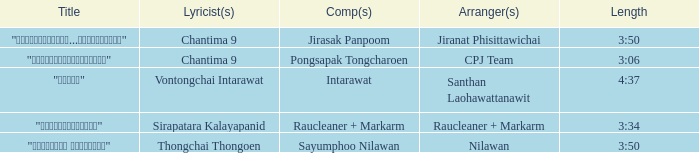Who was the arranger of "ขอโทษ"? Santhan Laohawattanawit. Can you parse all the data within this table? {'header': ['Title', 'Lyricist(s)', 'Comp(s)', 'Arranger(s)', 'Length'], 'rows': [['"เรายังรักกัน...ไม่ใช่เหรอ"', 'Chantima 9', 'Jirasak Panpoom', 'Jiranat Phisittawichai', '3:50'], ['"นางฟ้าตาชั้นเดียว"', 'Chantima 9', 'Pongsapak Tongcharoen', 'CPJ Team', '3:06'], ['"ขอโทษ"', 'Vontongchai Intarawat', 'Intarawat', 'Santhan Laohawattanawit', '4:37'], ['"แค่อยากให้รู้"', 'Sirapatara Kalayapanid', 'Raucleaner + Markarm', 'Raucleaner + Markarm', '3:34'], ['"เลือกลืม เลือกจำ"', 'Thongchai Thongoen', 'Sayumphoo Nilawan', 'Nilawan', '3:50']]} 